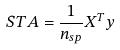<formula> <loc_0><loc_0><loc_500><loc_500>S T A = \frac { 1 } { n _ { s p } } X ^ { T } y</formula> 